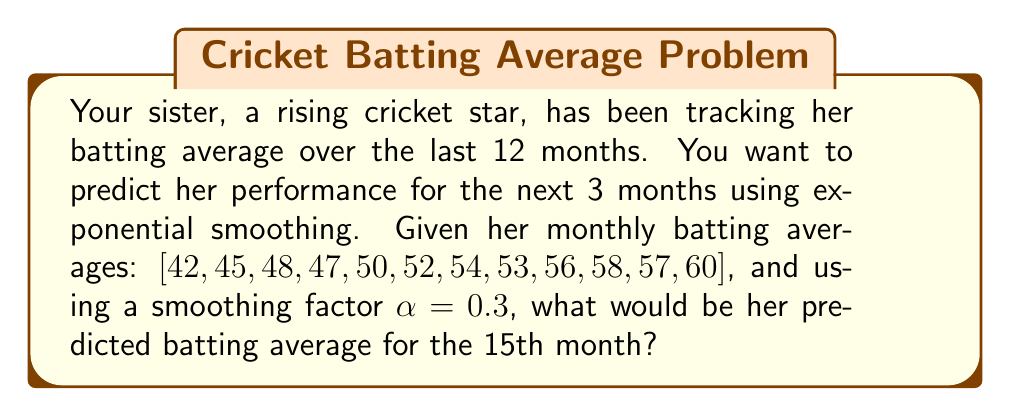Can you answer this question? To predict your sister's batting average using exponential smoothing, we'll follow these steps:

1) The exponential smoothing formula is:
   $$F_{t+1} = \alpha Y_t + (1-\alpha)F_t$$
   Where:
   $F_{t+1}$ is the forecast for the next period
   $Y_t$ is the actual value at time t
   $F_t$ is the forecast for the current period
   $\alpha$ is the smoothing factor (0 < α < 1)

2) We start with the initial forecast $F_1$ equal to the first actual value:
   $F_1 = 42$

3) We calculate subsequent forecasts:
   $F_2 = 0.3(42) + 0.7(42) = 42$
   $F_3 = 0.3(45) + 0.7(42) = 42.9$
   $F_4 = 0.3(48) + 0.7(42.9) = 44.43$
   ...and so on until $F_{13}$

4) The last three forecasts:
   $F_{13} = 0.3(60) + 0.7(55.0726) = 56.5508$
   $F_{14} = 0.3(60) + 0.7(56.5508) = 57.5856$
   $F_{15} = 0.3(60) + 0.7(57.5856) = 58.3099$

5) Therefore, the predicted batting average for the 15th month is approximately 58.31.
Answer: 58.31 